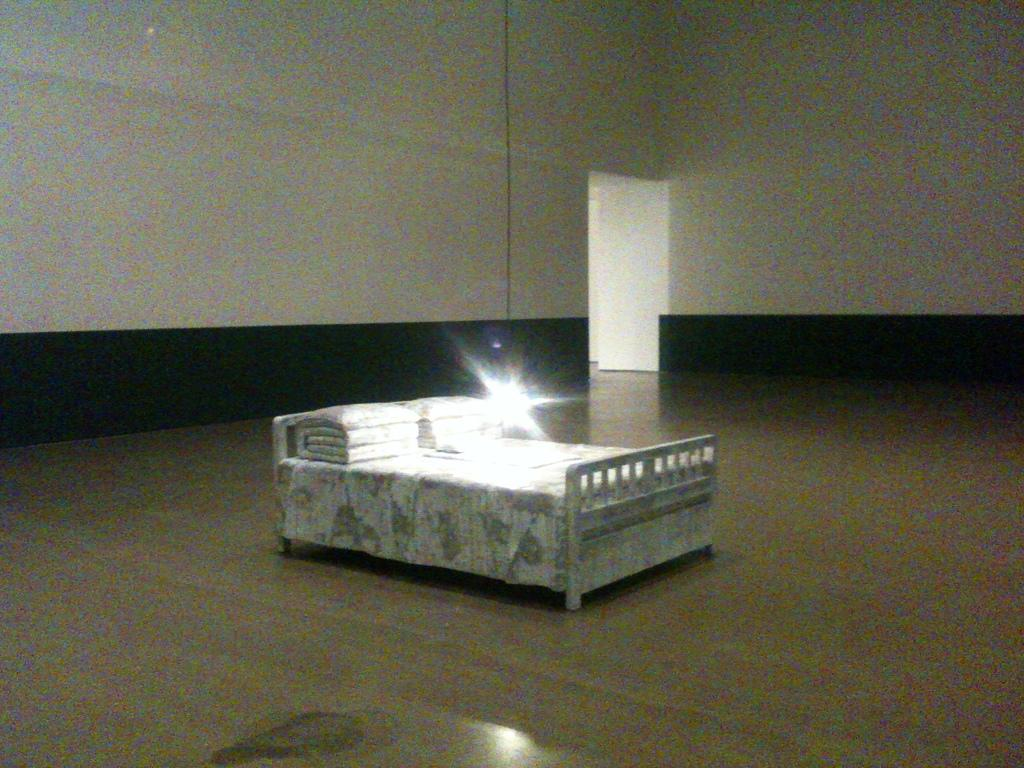What type of furniture is on the floor in the image? There is a white-colored bed on the floor. What is placed on the bed? Pillows are arranged on the bed. What can be seen near the bed? There is a light near the bed. What is visible in the background of the image? There is a white-colored door and a white-colored wall in the background. Can you tell me how many deer are visible in the image? There are no deer present in the image. What type of discovery was made in the room depicted in the image? There is no mention of any discovery in the image or its description. 